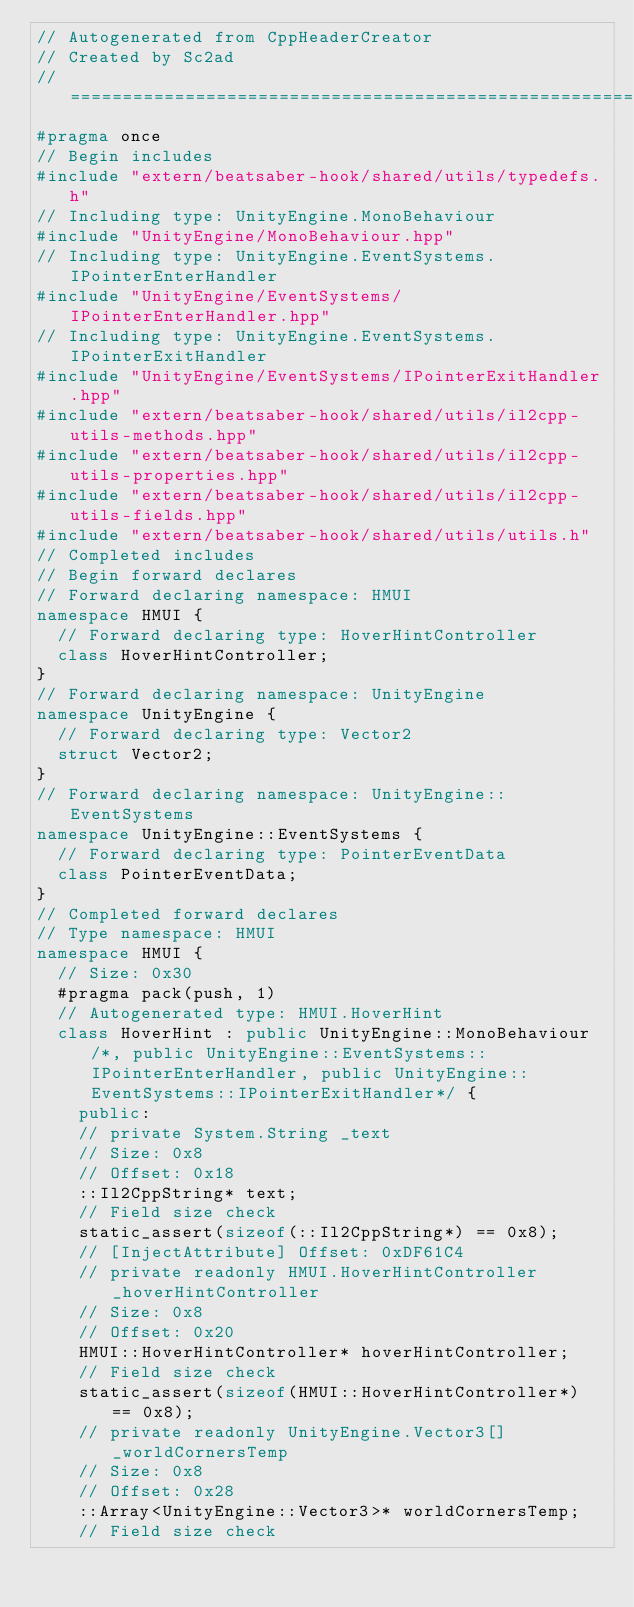Convert code to text. <code><loc_0><loc_0><loc_500><loc_500><_C++_>// Autogenerated from CppHeaderCreator
// Created by Sc2ad
// =========================================================================
#pragma once
// Begin includes
#include "extern/beatsaber-hook/shared/utils/typedefs.h"
// Including type: UnityEngine.MonoBehaviour
#include "UnityEngine/MonoBehaviour.hpp"
// Including type: UnityEngine.EventSystems.IPointerEnterHandler
#include "UnityEngine/EventSystems/IPointerEnterHandler.hpp"
// Including type: UnityEngine.EventSystems.IPointerExitHandler
#include "UnityEngine/EventSystems/IPointerExitHandler.hpp"
#include "extern/beatsaber-hook/shared/utils/il2cpp-utils-methods.hpp"
#include "extern/beatsaber-hook/shared/utils/il2cpp-utils-properties.hpp"
#include "extern/beatsaber-hook/shared/utils/il2cpp-utils-fields.hpp"
#include "extern/beatsaber-hook/shared/utils/utils.h"
// Completed includes
// Begin forward declares
// Forward declaring namespace: HMUI
namespace HMUI {
  // Forward declaring type: HoverHintController
  class HoverHintController;
}
// Forward declaring namespace: UnityEngine
namespace UnityEngine {
  // Forward declaring type: Vector2
  struct Vector2;
}
// Forward declaring namespace: UnityEngine::EventSystems
namespace UnityEngine::EventSystems {
  // Forward declaring type: PointerEventData
  class PointerEventData;
}
// Completed forward declares
// Type namespace: HMUI
namespace HMUI {
  // Size: 0x30
  #pragma pack(push, 1)
  // Autogenerated type: HMUI.HoverHint
  class HoverHint : public UnityEngine::MonoBehaviour/*, public UnityEngine::EventSystems::IPointerEnterHandler, public UnityEngine::EventSystems::IPointerExitHandler*/ {
    public:
    // private System.String _text
    // Size: 0x8
    // Offset: 0x18
    ::Il2CppString* text;
    // Field size check
    static_assert(sizeof(::Il2CppString*) == 0x8);
    // [InjectAttribute] Offset: 0xDF61C4
    // private readonly HMUI.HoverHintController _hoverHintController
    // Size: 0x8
    // Offset: 0x20
    HMUI::HoverHintController* hoverHintController;
    // Field size check
    static_assert(sizeof(HMUI::HoverHintController*) == 0x8);
    // private readonly UnityEngine.Vector3[] _worldCornersTemp
    // Size: 0x8
    // Offset: 0x28
    ::Array<UnityEngine::Vector3>* worldCornersTemp;
    // Field size check</code> 